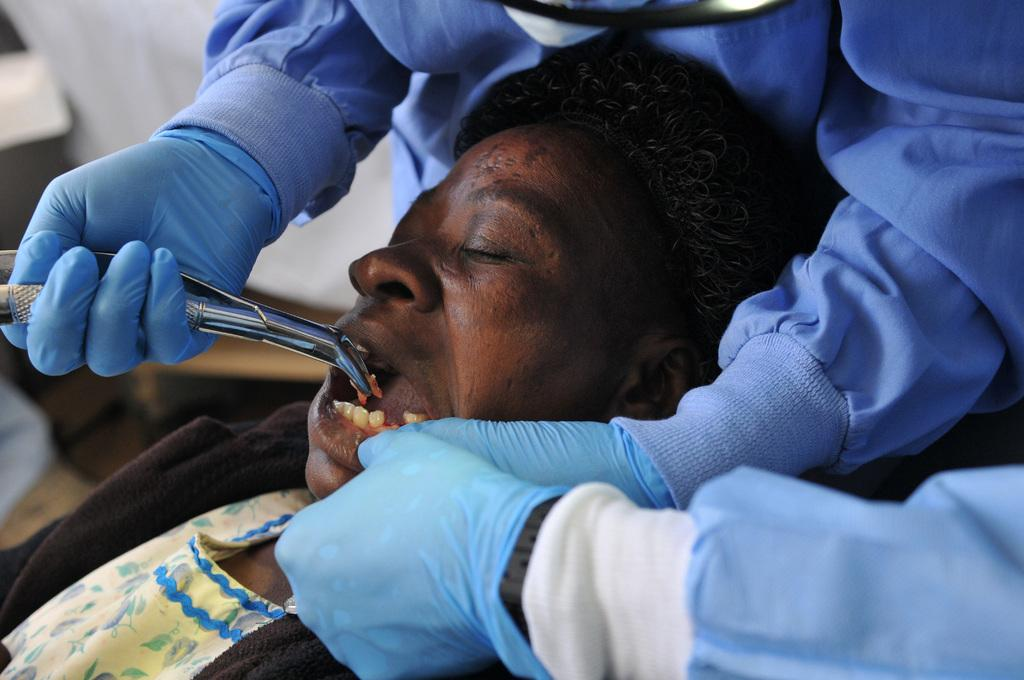How many people are in the image? There are two people in the image. What is the second man doing in the image? The second man is holding his mouth and removing his teeth. Can you describe the first person in the image? The facts provided do not give any details about the first person, so we cannot describe them. What type of floor can be seen in the image? There is no mention of a floor in the provided facts, so we cannot determine the type of floor in the image. 